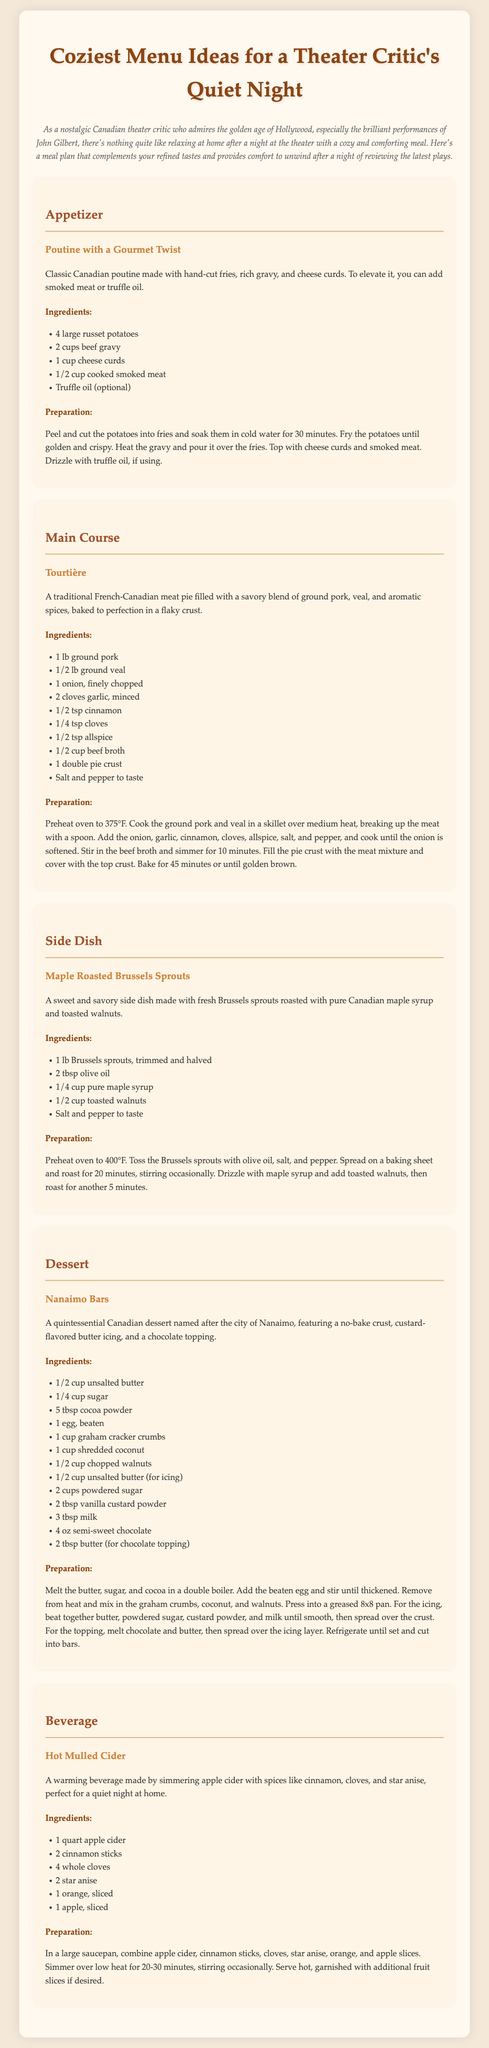What is the title of the document? The title of the document is provided in the heading section, which reflects the theme of the meal plan for a theater critic.
Answer: Coziest Menu Ideas for a Theater Critic's Quiet Night What is the main course dish? The main course dish is highlighted with a specific title and description in the document.
Answer: Tourtière How many ingredients are listed for the dessert? The number of ingredients can be counted from the section dedicated to the dessert recipe.
Answer: 11 What type of beverage is included in the meal plan? The beverage is specifically categorized and described in the menu, indicating its warming properties suitable for a quiet night.
Answer: Hot Mulled Cider What unique ingredient can be added to the poutine? The document mentions an optional ingredient that can enhance the classic dish, indicating a gourmet twist.
Answer: Truffle oil What is the preparation method for the Nanaimo bars described in the document? The method includes steps outlined in the dessert section, detailing how to create the Nanaimo bars.
Answer: No-bake What is the oven temperature for baking the Tourtière? The document specifies the oven setting needed to cook the main dish properly.
Answer: 375°F What vegetable is used in the side dish? The side dish section mentions the main vegetable ingredient used in the recipe.
Answer: Brussels sprouts How long should the maple roasted Brussels sprouts be roasted? The recommended cooking time for the Brussels sprouts is indicated in the preparation instructions.
Answer: 25 minutes 